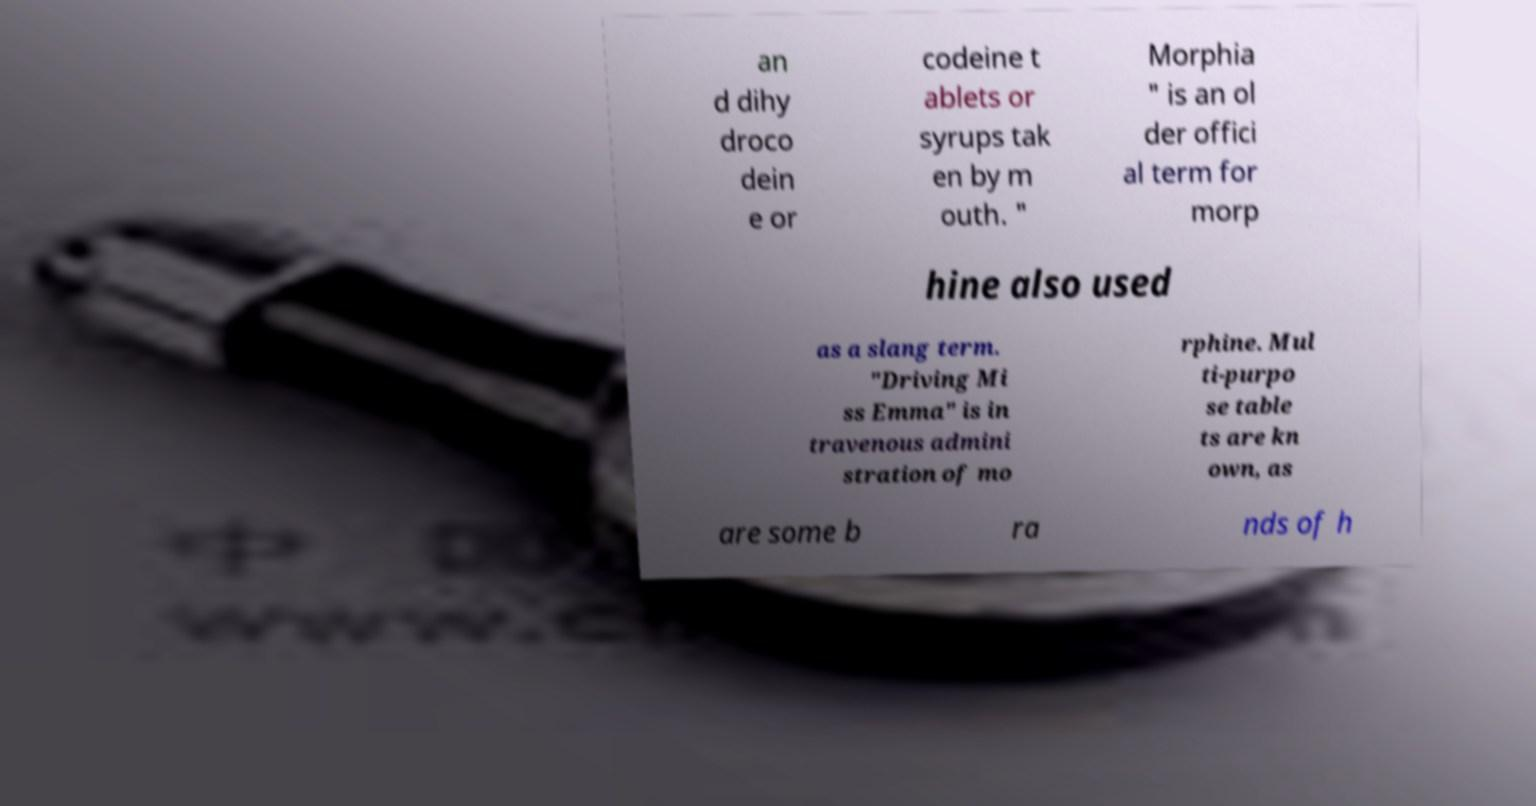There's text embedded in this image that I need extracted. Can you transcribe it verbatim? an d dihy droco dein e or codeine t ablets or syrups tak en by m outh. " Morphia " is an ol der offici al term for morp hine also used as a slang term. "Driving Mi ss Emma" is in travenous admini stration of mo rphine. Mul ti-purpo se table ts are kn own, as are some b ra nds of h 